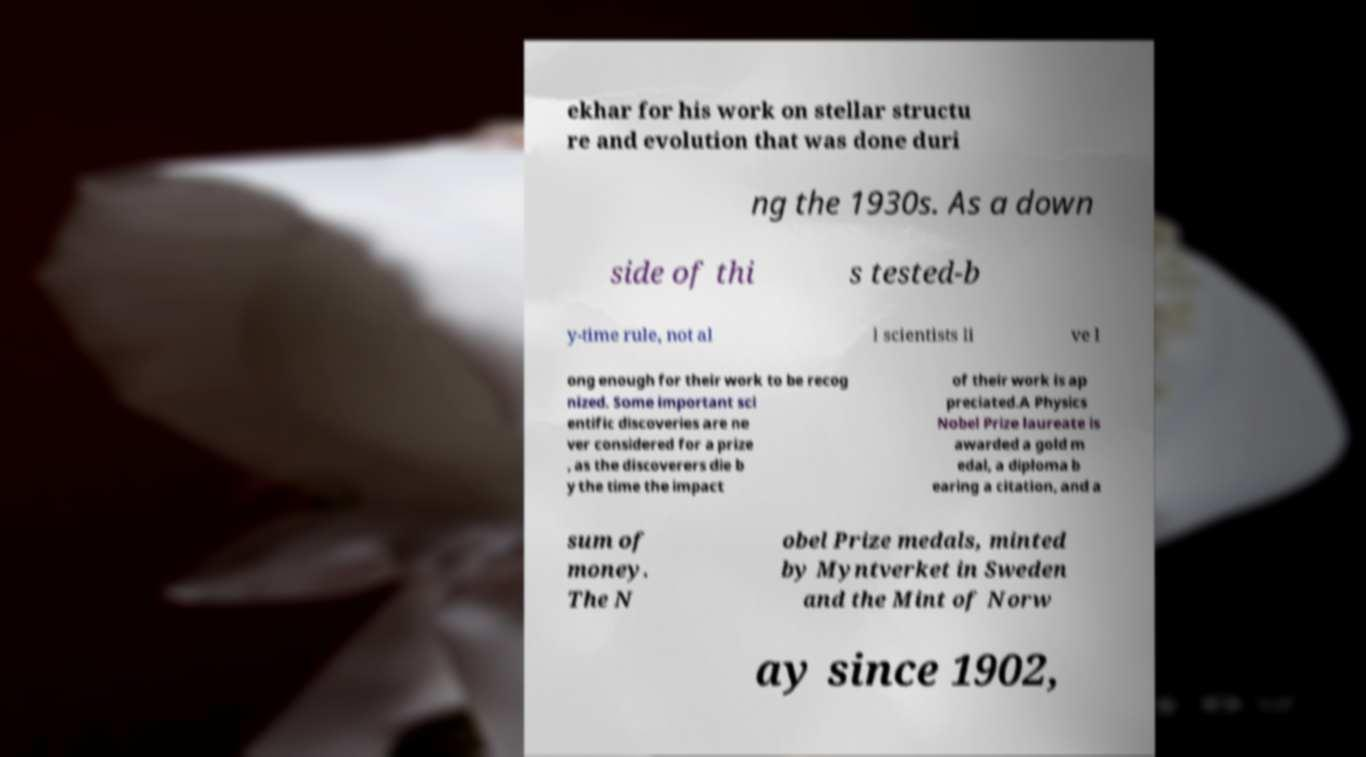Please identify and transcribe the text found in this image. ekhar for his work on stellar structu re and evolution that was done duri ng the 1930s. As a down side of thi s tested-b y-time rule, not al l scientists li ve l ong enough for their work to be recog nized. Some important sci entific discoveries are ne ver considered for a prize , as the discoverers die b y the time the impact of their work is ap preciated.A Physics Nobel Prize laureate is awarded a gold m edal, a diploma b earing a citation, and a sum of money. The N obel Prize medals, minted by Myntverket in Sweden and the Mint of Norw ay since 1902, 